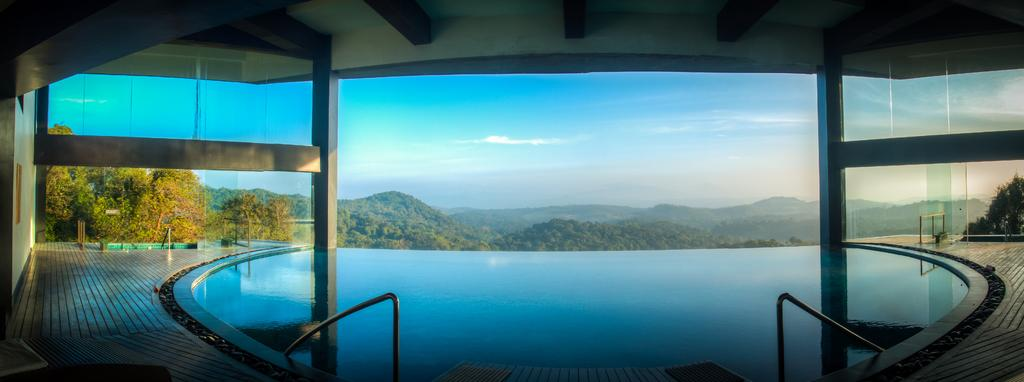What type of structure can be seen in the image? There is a wall and pillars with a roof in the image. What can be found in the corners of the image? There are trees in both the left and right corners of the image. What is visible in the background of the image? There is water, trees, and mountains visible in the background of the image. What part of the natural environment is visible at the top of the image? The sky is visible at the top of the image. What type of poisonous berry can be seen growing on the trees in the image? There are no berries, poisonous or otherwise, visible on the trees in the image. 